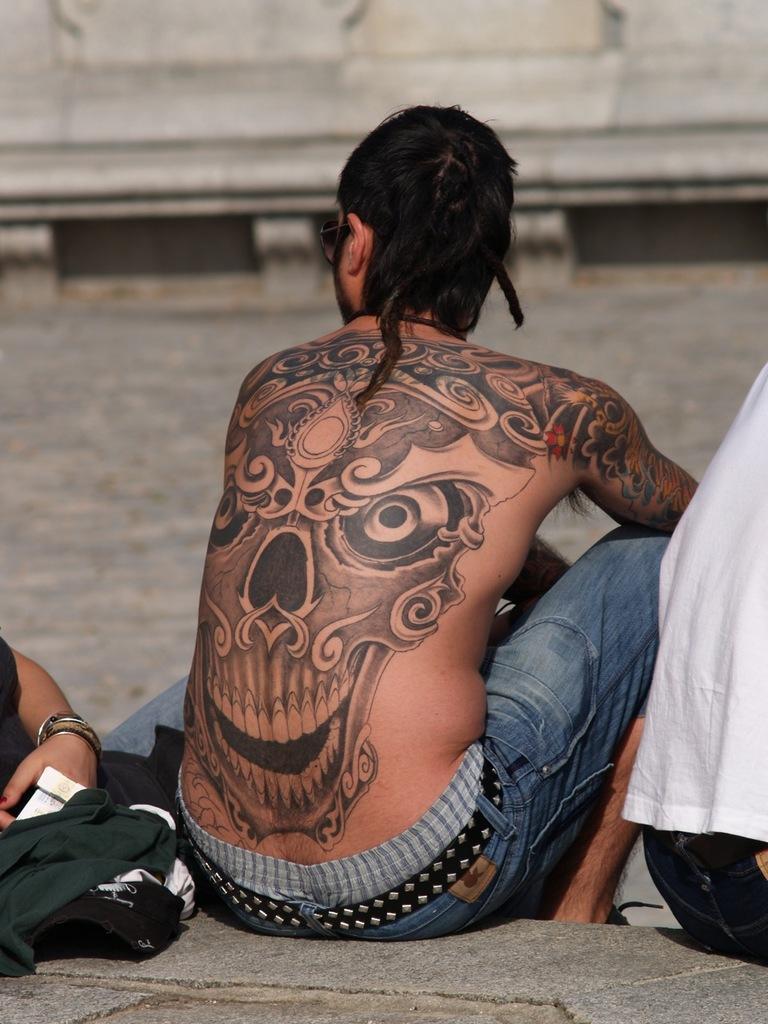Describe this image in one or two sentences. In this image few persons are sitting on the floor. Person at the middle of the image is having a tattoo on his back. There are few clothes on the floor. Before them there is water. Behind there is a bridge. 